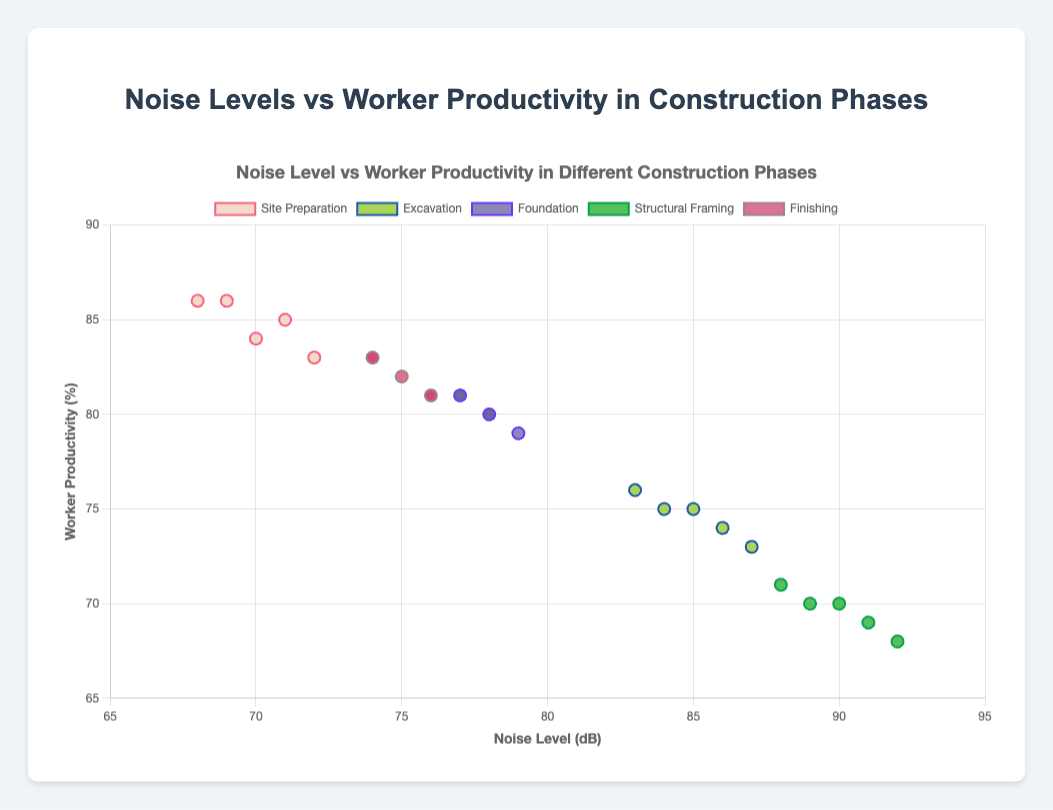What phase shows the highest average noise level and how does it impact worker productivity? Structural Framing shows the highest average noise level at 90 dB. This phase also has the lowest worker productivity at 70%.
Answer: Structural Framing; 90 dB; 70% Which construction phase has the least variability in noise levels over the days tracked? Foundation phase has the noise levels closely ranged between 77 dB and 79 dB, showing the least variability.
Answer: Foundation Which construction phase shows the highest worker productivity and what is its average noise level? Site Preparation shows the highest worker productivity at 85% and its average noise level is 70 dB.
Answer: Site Preparation; 85%; 70 dB How does the average noise level in the Excavation phase compare to the Finishing phase? The average noise level in the Excavation phase (85 dB) is higher than in the Finishing phase (75 dB).
Answer: Excavation; 85 dB; Finishing; 75 dB On which day during the Site Preparation phase was the noise level highest and what was the productivity on that day? On Day 1, the noise level was 72 dB and the productivity was 83%.
Answer: Day 1; 72 dB; 83% If you were to average the productivity percentages of the first and last days in each phase, which phase would have the highest value? For each phase, calculate the average productivity over the first and last days: 
Site Preparation (83+86)/2 = 84.5, Excavation (74+76)/2 = 75, Foundation (81+80)/2 = 80.5, Structural Framing (69+71)/2 = 70, Finishing (81+83)/2 = 82. The highest value is in the Site Preparation phase with 84.5%.
Answer: Site Preparation; 84.5% Which phase has the closest match between noise levels and productivity values within its data points? In the Finishing phase, the noise and productivity values are closely matched: (76,81), (74,83), (75,82), (76,81), (74,83)
Answer: Finishing How does the productivity change when the noise level decreases from 91 dB to 88 dB during the Structural Framing phase? Productivity changes from 69% to 71% when the noise level decreases from 91 dB to 88 dB.
Answer: Increases by 2% Which phase has productivity most consistent despite fluctuations in noise levels? Finishing phase has consistent productivity, ranging from 81% to 83% despite noise levels fluctuating from 74 dB to 76 dB.
Answer: Finishing 